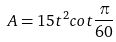Convert formula to latex. <formula><loc_0><loc_0><loc_500><loc_500>A = 1 5 t ^ { 2 } c o t \frac { \pi } { 6 0 }</formula> 